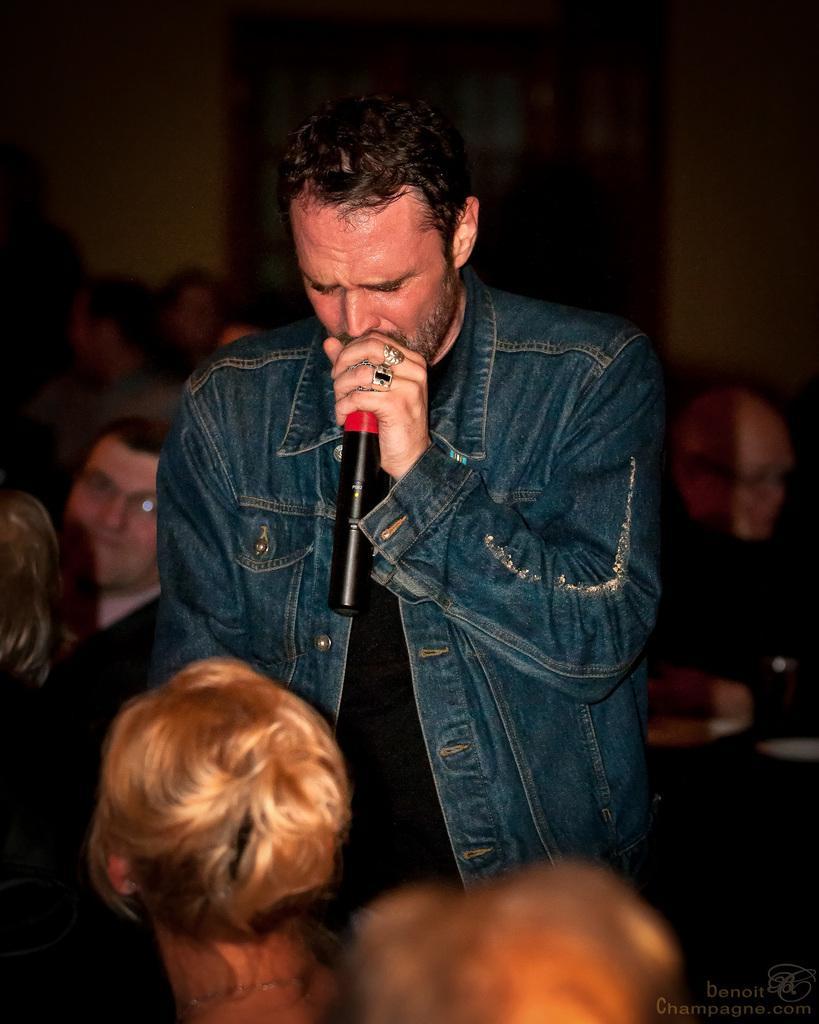How would you summarize this image in a sentence or two? This picture shows a man standing and talking holding a mic in his hand. There are some people sitting and watching him. In the background there is a wall. 